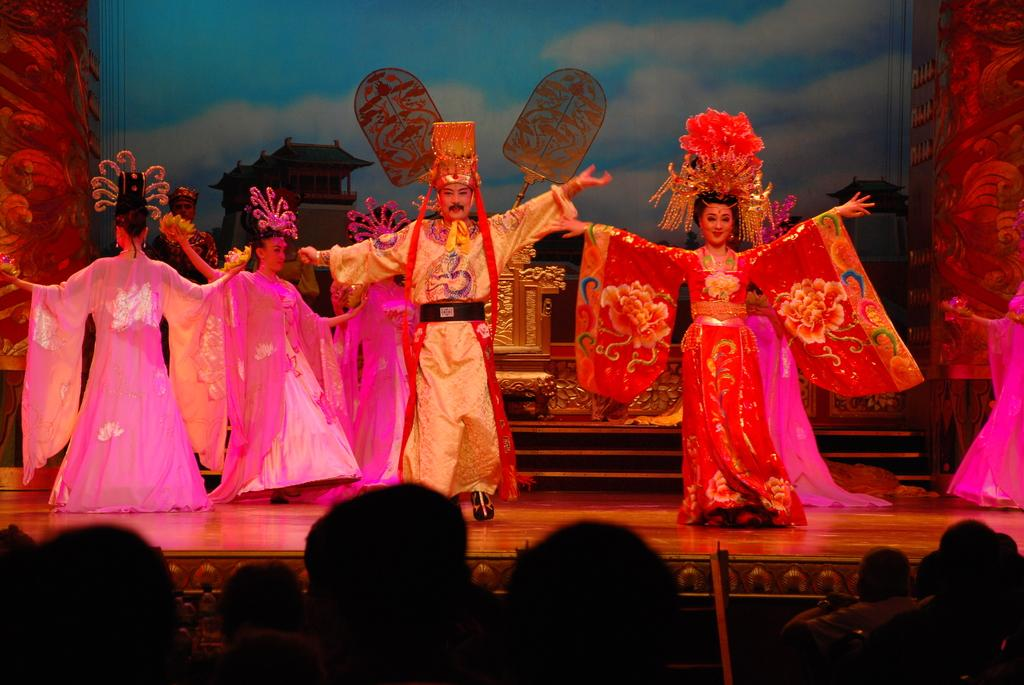What are the people in the image doing? The people in the image are dancing on a stage. Can you describe the location of the people in the image? There are people dancing on a stage, and there are also people visible at the bottom of the image. What type of cord is being used to improve the acoustics in the image? There is no mention of a cord or acoustics in the image; it simply shows people dancing on a stage and others at the bottom. 